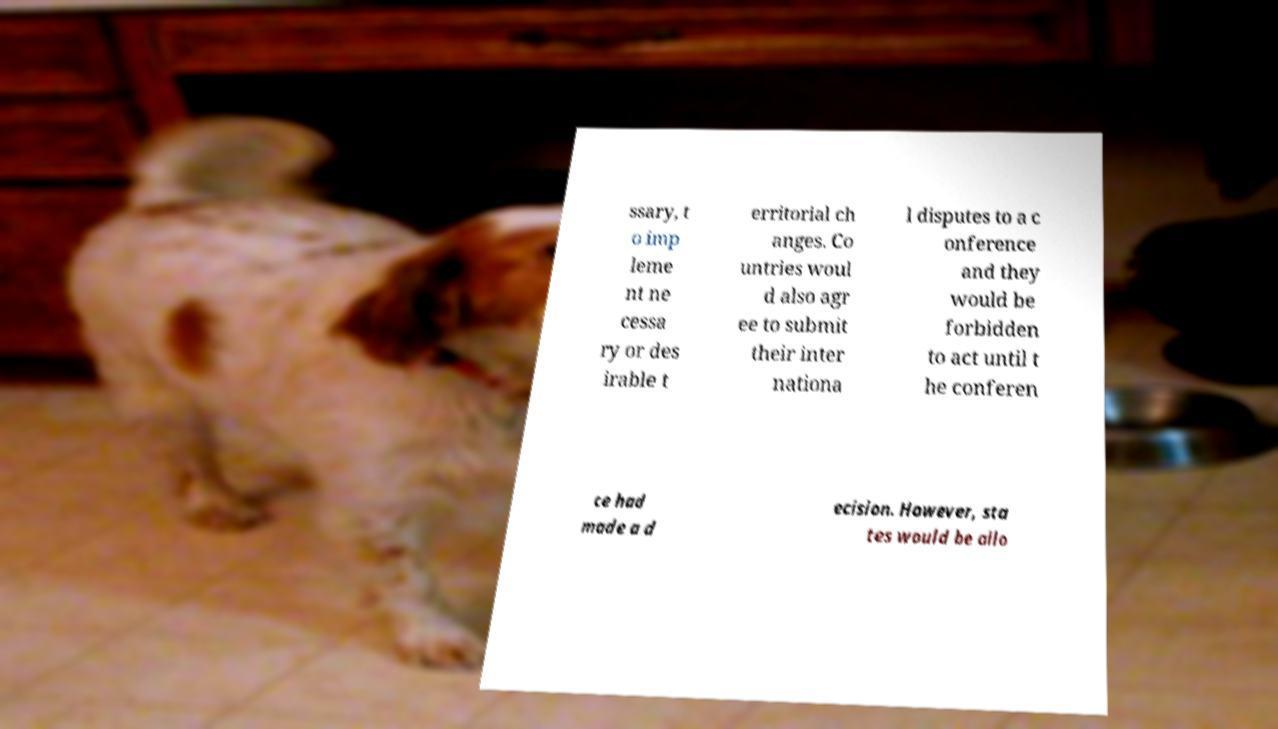Please identify and transcribe the text found in this image. ssary, t o imp leme nt ne cessa ry or des irable t erritorial ch anges. Co untries woul d also agr ee to submit their inter nationa l disputes to a c onference and they would be forbidden to act until t he conferen ce had made a d ecision. However, sta tes would be allo 